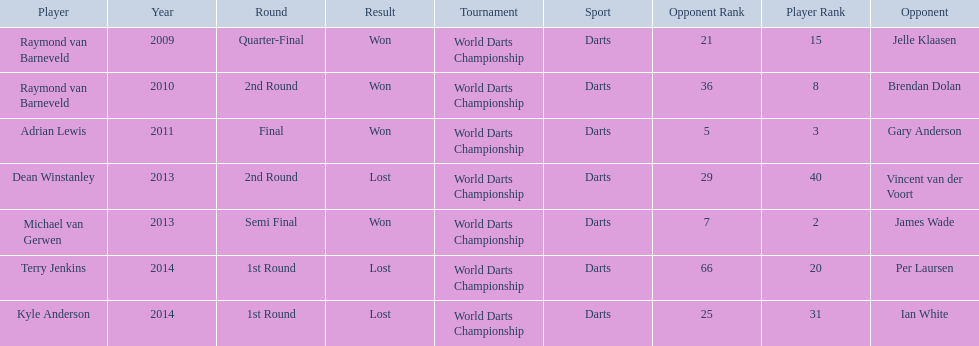Who are all the players? Raymond van Barneveld, Raymond van Barneveld, Adrian Lewis, Dean Winstanley, Michael van Gerwen, Terry Jenkins, Kyle Anderson. When did they play? 2009, 2010, 2011, 2013, 2013, 2014, 2014. And which player played in 2011? Adrian Lewis. 